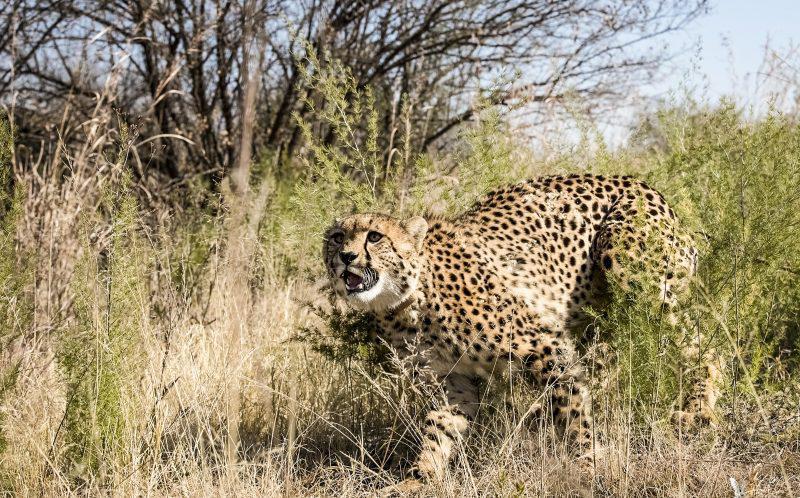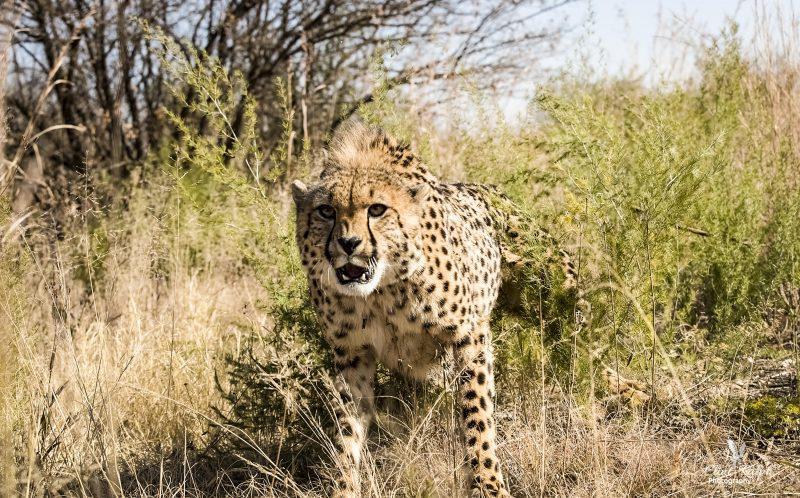The first image is the image on the left, the second image is the image on the right. For the images displayed, is the sentence "The left and right image contains the same number of cheetahs." factually correct? Answer yes or no. Yes. The first image is the image on the left, the second image is the image on the right. Considering the images on both sides, is "The right image contains a single cheetah." valid? Answer yes or no. Yes. 